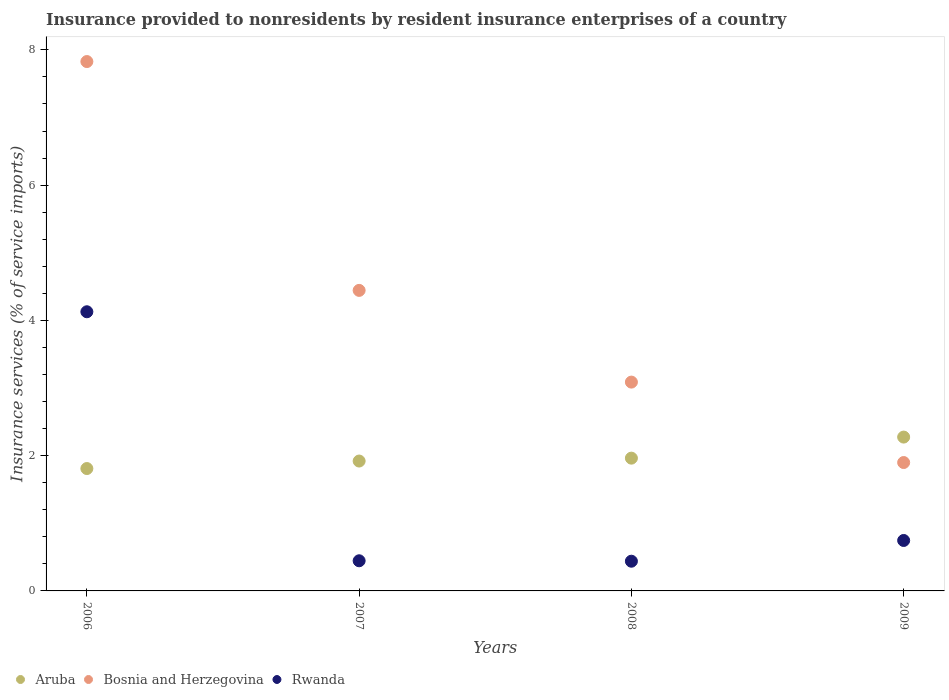How many different coloured dotlines are there?
Offer a terse response. 3. Is the number of dotlines equal to the number of legend labels?
Your answer should be compact. Yes. What is the insurance provided to nonresidents in Aruba in 2009?
Offer a terse response. 2.27. Across all years, what is the maximum insurance provided to nonresidents in Rwanda?
Provide a succinct answer. 4.13. Across all years, what is the minimum insurance provided to nonresidents in Rwanda?
Your response must be concise. 0.44. In which year was the insurance provided to nonresidents in Rwanda maximum?
Your answer should be compact. 2006. What is the total insurance provided to nonresidents in Bosnia and Herzegovina in the graph?
Give a very brief answer. 17.26. What is the difference between the insurance provided to nonresidents in Rwanda in 2007 and that in 2008?
Keep it short and to the point. 0.01. What is the difference between the insurance provided to nonresidents in Rwanda in 2007 and the insurance provided to nonresidents in Aruba in 2009?
Your answer should be compact. -1.83. What is the average insurance provided to nonresidents in Bosnia and Herzegovina per year?
Provide a succinct answer. 4.31. In the year 2009, what is the difference between the insurance provided to nonresidents in Bosnia and Herzegovina and insurance provided to nonresidents in Aruba?
Provide a short and direct response. -0.38. What is the ratio of the insurance provided to nonresidents in Bosnia and Herzegovina in 2007 to that in 2009?
Your answer should be very brief. 2.34. Is the insurance provided to nonresidents in Aruba in 2006 less than that in 2009?
Offer a terse response. Yes. What is the difference between the highest and the second highest insurance provided to nonresidents in Aruba?
Keep it short and to the point. 0.31. What is the difference between the highest and the lowest insurance provided to nonresidents in Rwanda?
Your answer should be compact. 3.69. In how many years, is the insurance provided to nonresidents in Aruba greater than the average insurance provided to nonresidents in Aruba taken over all years?
Your response must be concise. 1. Is the sum of the insurance provided to nonresidents in Aruba in 2006 and 2009 greater than the maximum insurance provided to nonresidents in Rwanda across all years?
Give a very brief answer. No. Is it the case that in every year, the sum of the insurance provided to nonresidents in Rwanda and insurance provided to nonresidents in Bosnia and Herzegovina  is greater than the insurance provided to nonresidents in Aruba?
Your answer should be compact. Yes. How many dotlines are there?
Your answer should be compact. 3. What is the difference between two consecutive major ticks on the Y-axis?
Give a very brief answer. 2. Does the graph contain any zero values?
Offer a terse response. No. How many legend labels are there?
Provide a succinct answer. 3. What is the title of the graph?
Make the answer very short. Insurance provided to nonresidents by resident insurance enterprises of a country. What is the label or title of the X-axis?
Your answer should be compact. Years. What is the label or title of the Y-axis?
Offer a terse response. Insurance services (% of service imports). What is the Insurance services (% of service imports) of Aruba in 2006?
Your response must be concise. 1.81. What is the Insurance services (% of service imports) of Bosnia and Herzegovina in 2006?
Your answer should be compact. 7.83. What is the Insurance services (% of service imports) of Rwanda in 2006?
Your response must be concise. 4.13. What is the Insurance services (% of service imports) in Aruba in 2007?
Your response must be concise. 1.92. What is the Insurance services (% of service imports) of Bosnia and Herzegovina in 2007?
Keep it short and to the point. 4.44. What is the Insurance services (% of service imports) of Rwanda in 2007?
Make the answer very short. 0.45. What is the Insurance services (% of service imports) in Aruba in 2008?
Provide a short and direct response. 1.96. What is the Insurance services (% of service imports) in Bosnia and Herzegovina in 2008?
Give a very brief answer. 3.09. What is the Insurance services (% of service imports) of Rwanda in 2008?
Make the answer very short. 0.44. What is the Insurance services (% of service imports) in Aruba in 2009?
Offer a very short reply. 2.27. What is the Insurance services (% of service imports) in Bosnia and Herzegovina in 2009?
Provide a succinct answer. 1.9. What is the Insurance services (% of service imports) of Rwanda in 2009?
Provide a short and direct response. 0.75. Across all years, what is the maximum Insurance services (% of service imports) in Aruba?
Keep it short and to the point. 2.27. Across all years, what is the maximum Insurance services (% of service imports) of Bosnia and Herzegovina?
Ensure brevity in your answer.  7.83. Across all years, what is the maximum Insurance services (% of service imports) in Rwanda?
Offer a terse response. 4.13. Across all years, what is the minimum Insurance services (% of service imports) of Aruba?
Your response must be concise. 1.81. Across all years, what is the minimum Insurance services (% of service imports) in Bosnia and Herzegovina?
Your response must be concise. 1.9. Across all years, what is the minimum Insurance services (% of service imports) of Rwanda?
Make the answer very short. 0.44. What is the total Insurance services (% of service imports) of Aruba in the graph?
Your response must be concise. 7.97. What is the total Insurance services (% of service imports) in Bosnia and Herzegovina in the graph?
Offer a terse response. 17.26. What is the total Insurance services (% of service imports) in Rwanda in the graph?
Provide a succinct answer. 5.76. What is the difference between the Insurance services (% of service imports) of Aruba in 2006 and that in 2007?
Offer a terse response. -0.11. What is the difference between the Insurance services (% of service imports) in Bosnia and Herzegovina in 2006 and that in 2007?
Provide a succinct answer. 3.38. What is the difference between the Insurance services (% of service imports) of Rwanda in 2006 and that in 2007?
Provide a succinct answer. 3.68. What is the difference between the Insurance services (% of service imports) in Aruba in 2006 and that in 2008?
Give a very brief answer. -0.15. What is the difference between the Insurance services (% of service imports) in Bosnia and Herzegovina in 2006 and that in 2008?
Make the answer very short. 4.74. What is the difference between the Insurance services (% of service imports) of Rwanda in 2006 and that in 2008?
Your answer should be compact. 3.69. What is the difference between the Insurance services (% of service imports) in Aruba in 2006 and that in 2009?
Offer a very short reply. -0.47. What is the difference between the Insurance services (% of service imports) in Bosnia and Herzegovina in 2006 and that in 2009?
Offer a very short reply. 5.93. What is the difference between the Insurance services (% of service imports) in Rwanda in 2006 and that in 2009?
Give a very brief answer. 3.38. What is the difference between the Insurance services (% of service imports) in Aruba in 2007 and that in 2008?
Give a very brief answer. -0.04. What is the difference between the Insurance services (% of service imports) of Bosnia and Herzegovina in 2007 and that in 2008?
Offer a very short reply. 1.36. What is the difference between the Insurance services (% of service imports) of Rwanda in 2007 and that in 2008?
Offer a very short reply. 0.01. What is the difference between the Insurance services (% of service imports) in Aruba in 2007 and that in 2009?
Keep it short and to the point. -0.35. What is the difference between the Insurance services (% of service imports) in Bosnia and Herzegovina in 2007 and that in 2009?
Your answer should be very brief. 2.55. What is the difference between the Insurance services (% of service imports) in Rwanda in 2007 and that in 2009?
Your answer should be compact. -0.3. What is the difference between the Insurance services (% of service imports) in Aruba in 2008 and that in 2009?
Your answer should be very brief. -0.31. What is the difference between the Insurance services (% of service imports) of Bosnia and Herzegovina in 2008 and that in 2009?
Give a very brief answer. 1.19. What is the difference between the Insurance services (% of service imports) in Rwanda in 2008 and that in 2009?
Give a very brief answer. -0.31. What is the difference between the Insurance services (% of service imports) in Aruba in 2006 and the Insurance services (% of service imports) in Bosnia and Herzegovina in 2007?
Your answer should be compact. -2.63. What is the difference between the Insurance services (% of service imports) in Aruba in 2006 and the Insurance services (% of service imports) in Rwanda in 2007?
Give a very brief answer. 1.36. What is the difference between the Insurance services (% of service imports) in Bosnia and Herzegovina in 2006 and the Insurance services (% of service imports) in Rwanda in 2007?
Give a very brief answer. 7.38. What is the difference between the Insurance services (% of service imports) in Aruba in 2006 and the Insurance services (% of service imports) in Bosnia and Herzegovina in 2008?
Offer a terse response. -1.28. What is the difference between the Insurance services (% of service imports) of Aruba in 2006 and the Insurance services (% of service imports) of Rwanda in 2008?
Your response must be concise. 1.37. What is the difference between the Insurance services (% of service imports) in Bosnia and Herzegovina in 2006 and the Insurance services (% of service imports) in Rwanda in 2008?
Your answer should be very brief. 7.39. What is the difference between the Insurance services (% of service imports) of Aruba in 2006 and the Insurance services (% of service imports) of Bosnia and Herzegovina in 2009?
Make the answer very short. -0.09. What is the difference between the Insurance services (% of service imports) of Aruba in 2006 and the Insurance services (% of service imports) of Rwanda in 2009?
Offer a very short reply. 1.06. What is the difference between the Insurance services (% of service imports) in Bosnia and Herzegovina in 2006 and the Insurance services (% of service imports) in Rwanda in 2009?
Your response must be concise. 7.08. What is the difference between the Insurance services (% of service imports) of Aruba in 2007 and the Insurance services (% of service imports) of Bosnia and Herzegovina in 2008?
Keep it short and to the point. -1.17. What is the difference between the Insurance services (% of service imports) of Aruba in 2007 and the Insurance services (% of service imports) of Rwanda in 2008?
Provide a succinct answer. 1.48. What is the difference between the Insurance services (% of service imports) in Bosnia and Herzegovina in 2007 and the Insurance services (% of service imports) in Rwanda in 2008?
Offer a very short reply. 4. What is the difference between the Insurance services (% of service imports) in Aruba in 2007 and the Insurance services (% of service imports) in Bosnia and Herzegovina in 2009?
Ensure brevity in your answer.  0.02. What is the difference between the Insurance services (% of service imports) of Aruba in 2007 and the Insurance services (% of service imports) of Rwanda in 2009?
Ensure brevity in your answer.  1.17. What is the difference between the Insurance services (% of service imports) in Bosnia and Herzegovina in 2007 and the Insurance services (% of service imports) in Rwanda in 2009?
Ensure brevity in your answer.  3.7. What is the difference between the Insurance services (% of service imports) in Aruba in 2008 and the Insurance services (% of service imports) in Bosnia and Herzegovina in 2009?
Make the answer very short. 0.06. What is the difference between the Insurance services (% of service imports) in Aruba in 2008 and the Insurance services (% of service imports) in Rwanda in 2009?
Make the answer very short. 1.22. What is the difference between the Insurance services (% of service imports) of Bosnia and Herzegovina in 2008 and the Insurance services (% of service imports) of Rwanda in 2009?
Ensure brevity in your answer.  2.34. What is the average Insurance services (% of service imports) of Aruba per year?
Ensure brevity in your answer.  1.99. What is the average Insurance services (% of service imports) of Bosnia and Herzegovina per year?
Make the answer very short. 4.31. What is the average Insurance services (% of service imports) of Rwanda per year?
Provide a short and direct response. 1.44. In the year 2006, what is the difference between the Insurance services (% of service imports) in Aruba and Insurance services (% of service imports) in Bosnia and Herzegovina?
Ensure brevity in your answer.  -6.02. In the year 2006, what is the difference between the Insurance services (% of service imports) in Aruba and Insurance services (% of service imports) in Rwanda?
Provide a succinct answer. -2.32. In the year 2006, what is the difference between the Insurance services (% of service imports) of Bosnia and Herzegovina and Insurance services (% of service imports) of Rwanda?
Provide a short and direct response. 3.7. In the year 2007, what is the difference between the Insurance services (% of service imports) in Aruba and Insurance services (% of service imports) in Bosnia and Herzegovina?
Your answer should be very brief. -2.52. In the year 2007, what is the difference between the Insurance services (% of service imports) in Aruba and Insurance services (% of service imports) in Rwanda?
Your answer should be very brief. 1.47. In the year 2007, what is the difference between the Insurance services (% of service imports) of Bosnia and Herzegovina and Insurance services (% of service imports) of Rwanda?
Your answer should be compact. 4. In the year 2008, what is the difference between the Insurance services (% of service imports) in Aruba and Insurance services (% of service imports) in Bosnia and Herzegovina?
Your response must be concise. -1.12. In the year 2008, what is the difference between the Insurance services (% of service imports) of Aruba and Insurance services (% of service imports) of Rwanda?
Keep it short and to the point. 1.52. In the year 2008, what is the difference between the Insurance services (% of service imports) in Bosnia and Herzegovina and Insurance services (% of service imports) in Rwanda?
Ensure brevity in your answer.  2.65. In the year 2009, what is the difference between the Insurance services (% of service imports) of Aruba and Insurance services (% of service imports) of Bosnia and Herzegovina?
Your answer should be very brief. 0.38. In the year 2009, what is the difference between the Insurance services (% of service imports) of Aruba and Insurance services (% of service imports) of Rwanda?
Provide a short and direct response. 1.53. In the year 2009, what is the difference between the Insurance services (% of service imports) of Bosnia and Herzegovina and Insurance services (% of service imports) of Rwanda?
Give a very brief answer. 1.15. What is the ratio of the Insurance services (% of service imports) in Aruba in 2006 to that in 2007?
Keep it short and to the point. 0.94. What is the ratio of the Insurance services (% of service imports) in Bosnia and Herzegovina in 2006 to that in 2007?
Keep it short and to the point. 1.76. What is the ratio of the Insurance services (% of service imports) in Rwanda in 2006 to that in 2007?
Your response must be concise. 9.26. What is the ratio of the Insurance services (% of service imports) in Aruba in 2006 to that in 2008?
Your answer should be very brief. 0.92. What is the ratio of the Insurance services (% of service imports) of Bosnia and Herzegovina in 2006 to that in 2008?
Make the answer very short. 2.54. What is the ratio of the Insurance services (% of service imports) of Rwanda in 2006 to that in 2008?
Your response must be concise. 9.4. What is the ratio of the Insurance services (% of service imports) in Aruba in 2006 to that in 2009?
Your response must be concise. 0.8. What is the ratio of the Insurance services (% of service imports) in Bosnia and Herzegovina in 2006 to that in 2009?
Your response must be concise. 4.12. What is the ratio of the Insurance services (% of service imports) of Rwanda in 2006 to that in 2009?
Your response must be concise. 5.53. What is the ratio of the Insurance services (% of service imports) in Aruba in 2007 to that in 2008?
Provide a succinct answer. 0.98. What is the ratio of the Insurance services (% of service imports) in Bosnia and Herzegovina in 2007 to that in 2008?
Offer a very short reply. 1.44. What is the ratio of the Insurance services (% of service imports) of Rwanda in 2007 to that in 2008?
Provide a short and direct response. 1.01. What is the ratio of the Insurance services (% of service imports) of Aruba in 2007 to that in 2009?
Give a very brief answer. 0.84. What is the ratio of the Insurance services (% of service imports) of Bosnia and Herzegovina in 2007 to that in 2009?
Provide a succinct answer. 2.34. What is the ratio of the Insurance services (% of service imports) of Rwanda in 2007 to that in 2009?
Provide a short and direct response. 0.6. What is the ratio of the Insurance services (% of service imports) in Aruba in 2008 to that in 2009?
Make the answer very short. 0.86. What is the ratio of the Insurance services (% of service imports) in Bosnia and Herzegovina in 2008 to that in 2009?
Provide a short and direct response. 1.63. What is the ratio of the Insurance services (% of service imports) of Rwanda in 2008 to that in 2009?
Provide a short and direct response. 0.59. What is the difference between the highest and the second highest Insurance services (% of service imports) in Aruba?
Ensure brevity in your answer.  0.31. What is the difference between the highest and the second highest Insurance services (% of service imports) of Bosnia and Herzegovina?
Provide a short and direct response. 3.38. What is the difference between the highest and the second highest Insurance services (% of service imports) of Rwanda?
Ensure brevity in your answer.  3.38. What is the difference between the highest and the lowest Insurance services (% of service imports) of Aruba?
Provide a short and direct response. 0.47. What is the difference between the highest and the lowest Insurance services (% of service imports) of Bosnia and Herzegovina?
Provide a short and direct response. 5.93. What is the difference between the highest and the lowest Insurance services (% of service imports) of Rwanda?
Provide a succinct answer. 3.69. 